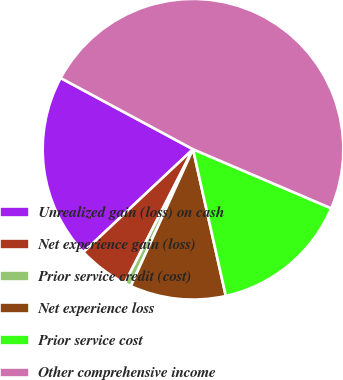Convert chart. <chart><loc_0><loc_0><loc_500><loc_500><pie_chart><fcel>Unrealized gain (loss) on cash<fcel>Net experience gain (loss)<fcel>Prior service credit (cost)<fcel>Net experience loss<fcel>Prior service cost<fcel>Other comprehensive income<nl><fcel>19.86%<fcel>5.5%<fcel>0.71%<fcel>10.29%<fcel>15.07%<fcel>48.57%<nl></chart> 